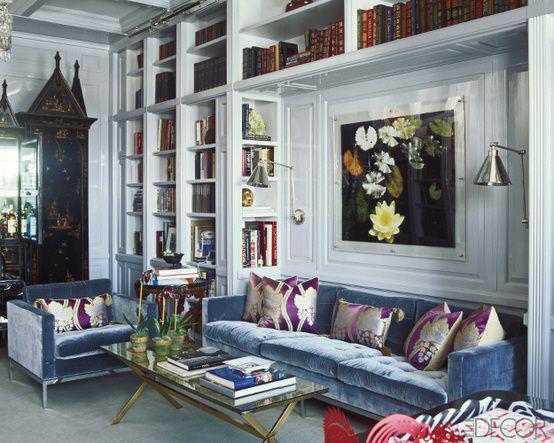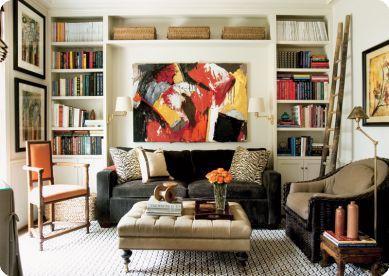The first image is the image on the left, the second image is the image on the right. Examine the images to the left and right. Is the description "One of the sofas has no coffee table before it in one of the images." accurate? Answer yes or no. No. The first image is the image on the left, the second image is the image on the right. Analyze the images presented: Is the assertion "Each image shows a single piece of art mounted on the wall behind a sofa flanked by bookshelves." valid? Answer yes or no. Yes. 